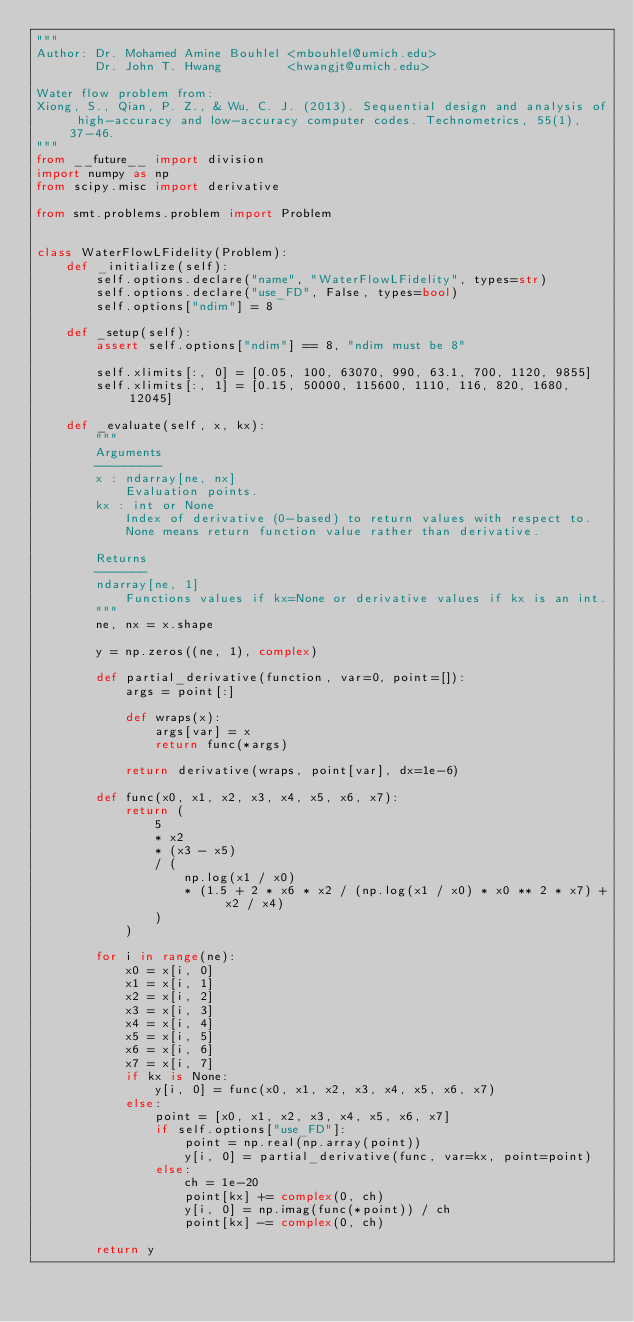<code> <loc_0><loc_0><loc_500><loc_500><_Python_>"""
Author: Dr. Mohamed Amine Bouhlel <mbouhlel@umich.edu>
        Dr. John T. Hwang         <hwangjt@umich.edu>

Water flow problem from:
Xiong, S., Qian, P. Z., & Wu, C. J. (2013). Sequential design and analysis of high-accuracy and low-accuracy computer codes. Technometrics, 55(1), 37-46.
"""
from __future__ import division
import numpy as np
from scipy.misc import derivative

from smt.problems.problem import Problem


class WaterFlowLFidelity(Problem):
    def _initialize(self):
        self.options.declare("name", "WaterFlowLFidelity", types=str)
        self.options.declare("use_FD", False, types=bool)
        self.options["ndim"] = 8

    def _setup(self):
        assert self.options["ndim"] == 8, "ndim must be 8"

        self.xlimits[:, 0] = [0.05, 100, 63070, 990, 63.1, 700, 1120, 9855]
        self.xlimits[:, 1] = [0.15, 50000, 115600, 1110, 116, 820, 1680, 12045]

    def _evaluate(self, x, kx):
        """
        Arguments
        ---------
        x : ndarray[ne, nx]
            Evaluation points.
        kx : int or None
            Index of derivative (0-based) to return values with respect to.
            None means return function value rather than derivative.

        Returns
        -------
        ndarray[ne, 1]
            Functions values if kx=None or derivative values if kx is an int.
        """
        ne, nx = x.shape

        y = np.zeros((ne, 1), complex)

        def partial_derivative(function, var=0, point=[]):
            args = point[:]

            def wraps(x):
                args[var] = x
                return func(*args)

            return derivative(wraps, point[var], dx=1e-6)

        def func(x0, x1, x2, x3, x4, x5, x6, x7):
            return (
                5
                * x2
                * (x3 - x5)
                / (
                    np.log(x1 / x0)
                    * (1.5 + 2 * x6 * x2 / (np.log(x1 / x0) * x0 ** 2 * x7) + x2 / x4)
                )
            )

        for i in range(ne):
            x0 = x[i, 0]
            x1 = x[i, 1]
            x2 = x[i, 2]
            x3 = x[i, 3]
            x4 = x[i, 4]
            x5 = x[i, 5]
            x6 = x[i, 6]
            x7 = x[i, 7]
            if kx is None:
                y[i, 0] = func(x0, x1, x2, x3, x4, x5, x6, x7)
            else:
                point = [x0, x1, x2, x3, x4, x5, x6, x7]
                if self.options["use_FD"]:
                    point = np.real(np.array(point))
                    y[i, 0] = partial_derivative(func, var=kx, point=point)
                else:
                    ch = 1e-20
                    point[kx] += complex(0, ch)
                    y[i, 0] = np.imag(func(*point)) / ch
                    point[kx] -= complex(0, ch)

        return y
</code> 